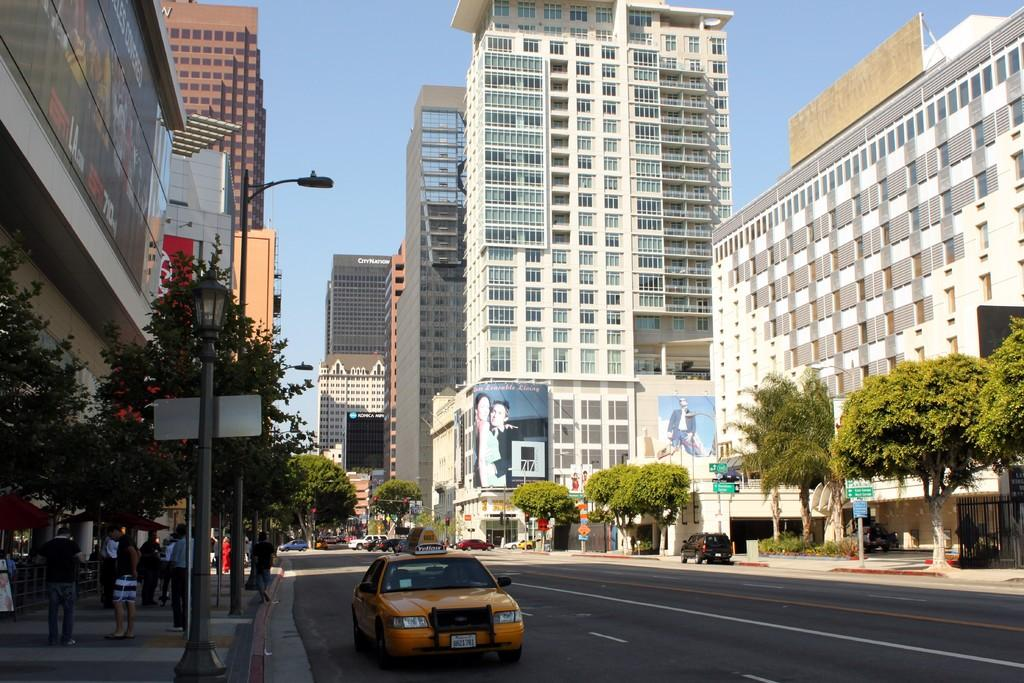What types of structures are visible in the image? There are buildings in the image. What natural elements can be seen in the image? There are trees and plants in the image. What man-made objects are present in the image? There are vehicles, boards, and posters in the image. Are there any living beings in the image? Yes, there are people in the image. What type of pie is being served by the secretary in the image? There is no secretary or pie present in the image. What angle is the camera positioned at in the image? The angle of the camera is not mentioned in the provided facts, and therefore cannot be determined from the image. 